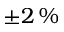Convert formula to latex. <formula><loc_0><loc_0><loc_500><loc_500>\pm 2 \, \%</formula> 